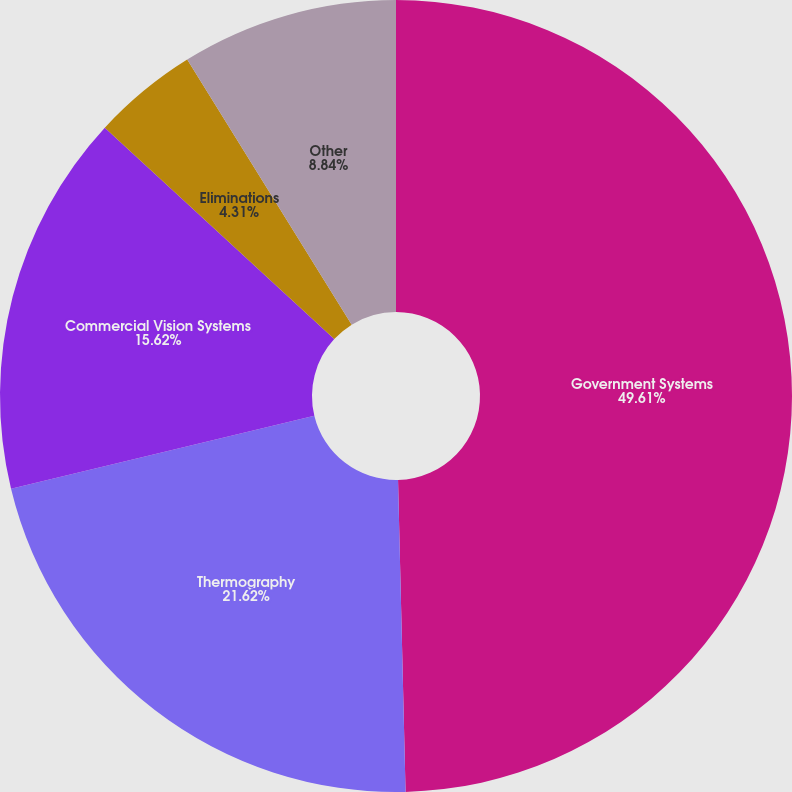Convert chart to OTSL. <chart><loc_0><loc_0><loc_500><loc_500><pie_chart><fcel>Government Systems<fcel>Thermography<fcel>Commercial Vision Systems<fcel>Eliminations<fcel>Other<nl><fcel>49.62%<fcel>21.62%<fcel>15.62%<fcel>4.31%<fcel>8.84%<nl></chart> 